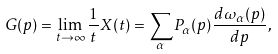Convert formula to latex. <formula><loc_0><loc_0><loc_500><loc_500>G ( p ) = \lim _ { t \to \infty } \frac { 1 } { t } X ( t ) = \sum _ { \alpha } P _ { \alpha } ( p ) \frac { d \omega _ { \alpha } ( p ) } { d p } ,</formula> 